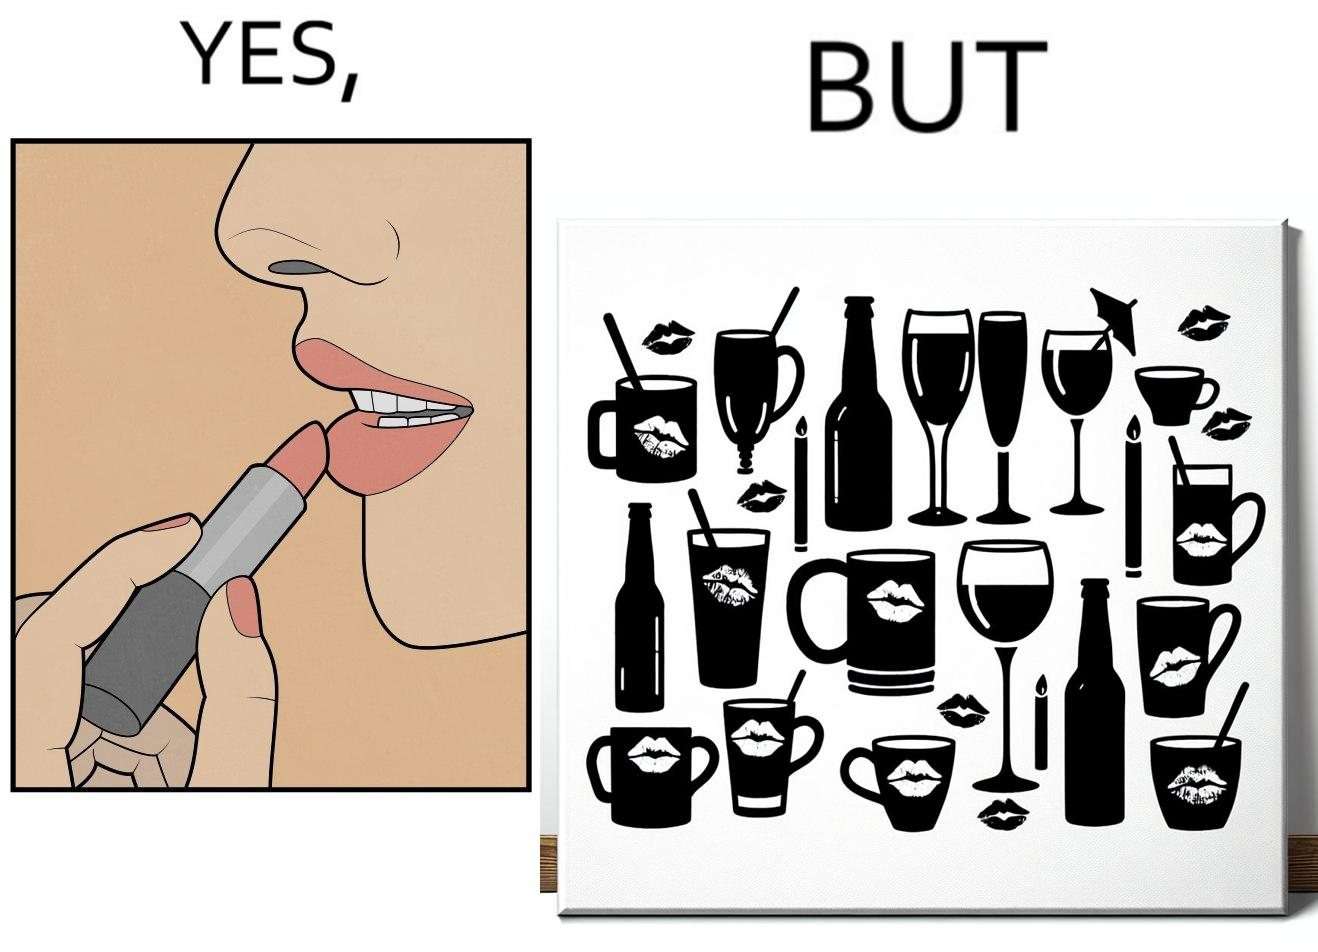Provide a description of this image. The image is ironic, because the left image suggest that a person applies lipsticks on their lips to make their lips look attractive or to keep them hydrated but on the contrary it gets sticked to the glasses or mugs and gets wasted 